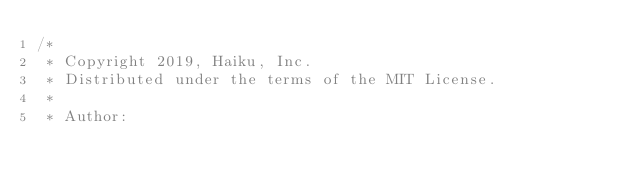Convert code to text. <code><loc_0><loc_0><loc_500><loc_500><_C++_>/*
 * Copyright 2019, Haiku, Inc.
 * Distributed under the terms of the MIT License.
 *
 * Author:</code> 